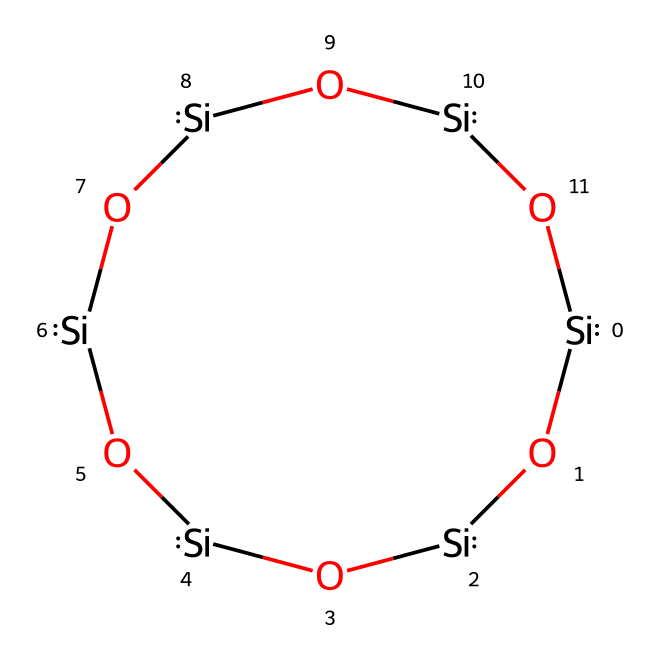What is the name of this chemical? The chemical has a structure that can be identified as quartz, which is primarily composed of silicon and oxygen in a tetrahedral framework. The specific arrangement of silicon and oxygen atoms in the provided SMILES representation is characteristic of quartz.
Answer: quartz How many silicon atoms are present in the structure? By analyzing the SMILES, we can count the number of silicon atoms indicated by the element symbol [Si], which appears six times in the given structure.
Answer: 6 How many oxygen atoms are present in the structure? The structure includes the element symbol [O], which appears four times in the SMILES representation. This indicates there are four oxygen atoms.
Answer: 4 What type of solid is quartz classified as? Quartz is categorized as a covalent network solid due to its strong covalent bonding between silicon and oxygen atoms, which results in a continuous three-dimensional network.
Answer: covalent network What is the coordination number of silicon in quartz? The coordination number of silicon in quartz is 4, as each silicon atom is surrounded by four oxygen atoms in a tetrahedral geometry.
Answer: 4 What property allows quartz to form a hexagonal crystal system? The internal arrangement, specifically the symmetrical tetrahedral bonding of silicon and oxygen, results in the hexagonal symmetry typical of quartz crystals.
Answer: symmetry What type of bonding is primarily present in quartz? The primary type of bonding in quartz is covalent bonding, which occurs due to the sharing of electrons between silicon and oxygen atoms, leading to a strong and stable structure.
Answer: covalent 